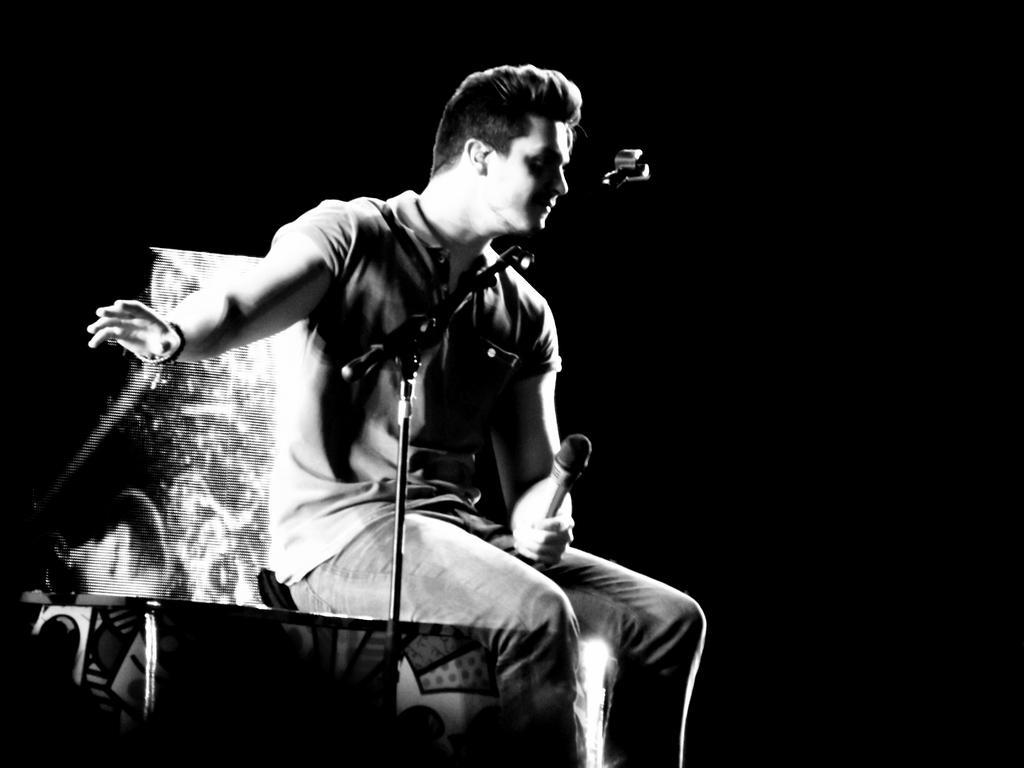Could you give a brief overview of what you see in this image? In this image I can see a dark view in the back ground and I can see a person sitting on table and holding a mike , in front of him I can see another mike 